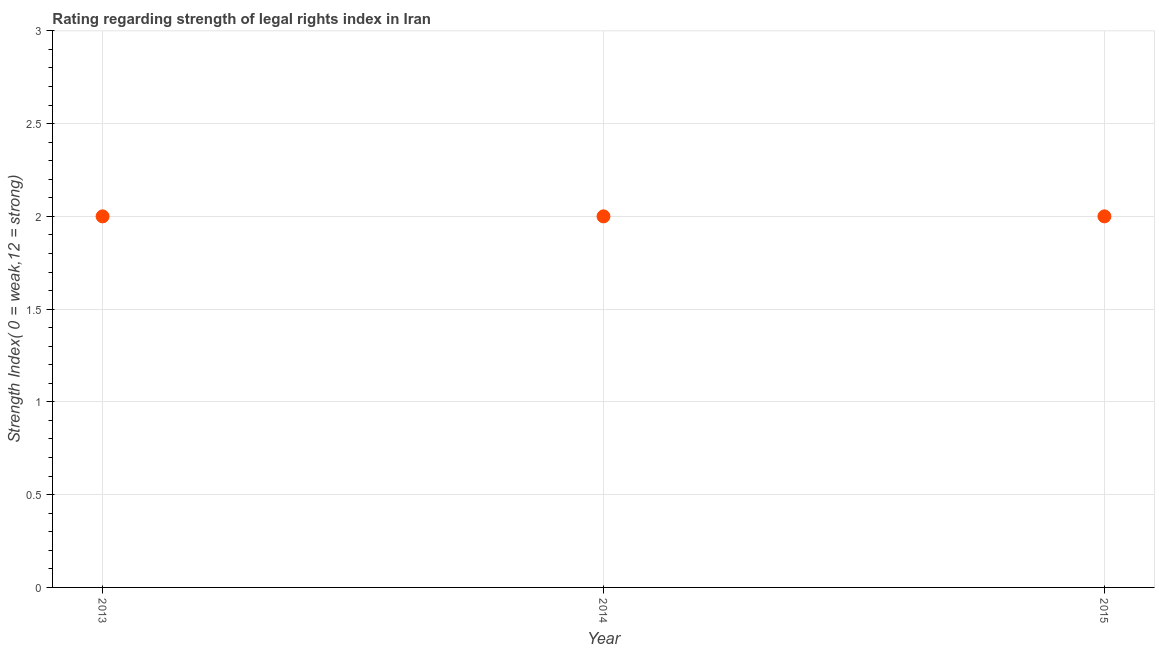What is the strength of legal rights index in 2014?
Your response must be concise. 2. Across all years, what is the maximum strength of legal rights index?
Offer a very short reply. 2. Across all years, what is the minimum strength of legal rights index?
Your response must be concise. 2. In which year was the strength of legal rights index maximum?
Provide a succinct answer. 2013. In which year was the strength of legal rights index minimum?
Make the answer very short. 2013. What is the difference between the strength of legal rights index in 2014 and 2015?
Provide a succinct answer. 0. What is the ratio of the strength of legal rights index in 2013 to that in 2014?
Offer a terse response. 1. Is the strength of legal rights index in 2014 less than that in 2015?
Provide a succinct answer. No. Is the difference between the strength of legal rights index in 2014 and 2015 greater than the difference between any two years?
Offer a very short reply. Yes. In how many years, is the strength of legal rights index greater than the average strength of legal rights index taken over all years?
Offer a very short reply. 0. How many years are there in the graph?
Provide a succinct answer. 3. What is the difference between two consecutive major ticks on the Y-axis?
Ensure brevity in your answer.  0.5. Are the values on the major ticks of Y-axis written in scientific E-notation?
Give a very brief answer. No. Does the graph contain any zero values?
Your answer should be very brief. No. What is the title of the graph?
Your response must be concise. Rating regarding strength of legal rights index in Iran. What is the label or title of the X-axis?
Make the answer very short. Year. What is the label or title of the Y-axis?
Offer a very short reply. Strength Index( 0 = weak,12 = strong). What is the Strength Index( 0 = weak,12 = strong) in 2013?
Your answer should be very brief. 2. What is the difference between the Strength Index( 0 = weak,12 = strong) in 2013 and 2015?
Offer a terse response. 0. What is the difference between the Strength Index( 0 = weak,12 = strong) in 2014 and 2015?
Provide a succinct answer. 0. What is the ratio of the Strength Index( 0 = weak,12 = strong) in 2013 to that in 2014?
Your response must be concise. 1. What is the ratio of the Strength Index( 0 = weak,12 = strong) in 2013 to that in 2015?
Ensure brevity in your answer.  1. 